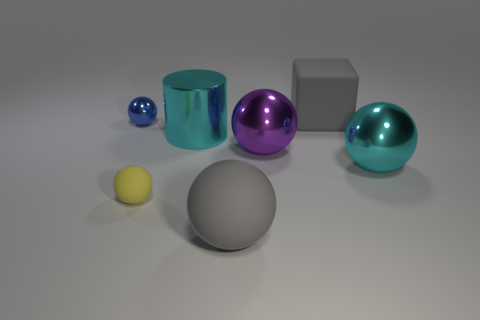Subtract all big gray spheres. How many spheres are left? 4 Add 1 green metal cubes. How many objects exist? 8 Subtract all yellow spheres. How many spheres are left? 4 Subtract all cylinders. How many objects are left? 6 Subtract 1 blocks. How many blocks are left? 0 Add 6 tiny blue objects. How many tiny blue objects are left? 7 Add 3 large cyan cylinders. How many large cyan cylinders exist? 4 Subtract 1 purple spheres. How many objects are left? 6 Subtract all yellow cylinders. Subtract all yellow cubes. How many cylinders are left? 1 Subtract all big objects. Subtract all tiny shiny balls. How many objects are left? 1 